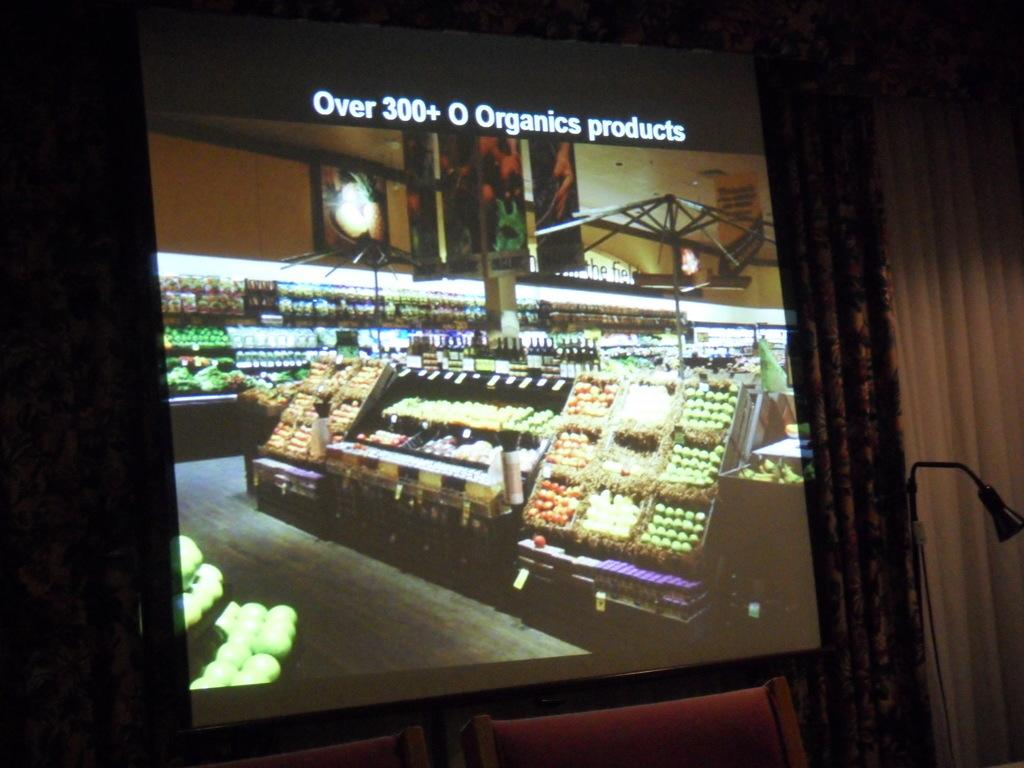Provide a one-sentence caption for the provided image. A projection screen shows the interior of a farmers market and boasts over 300 Organic Products. 